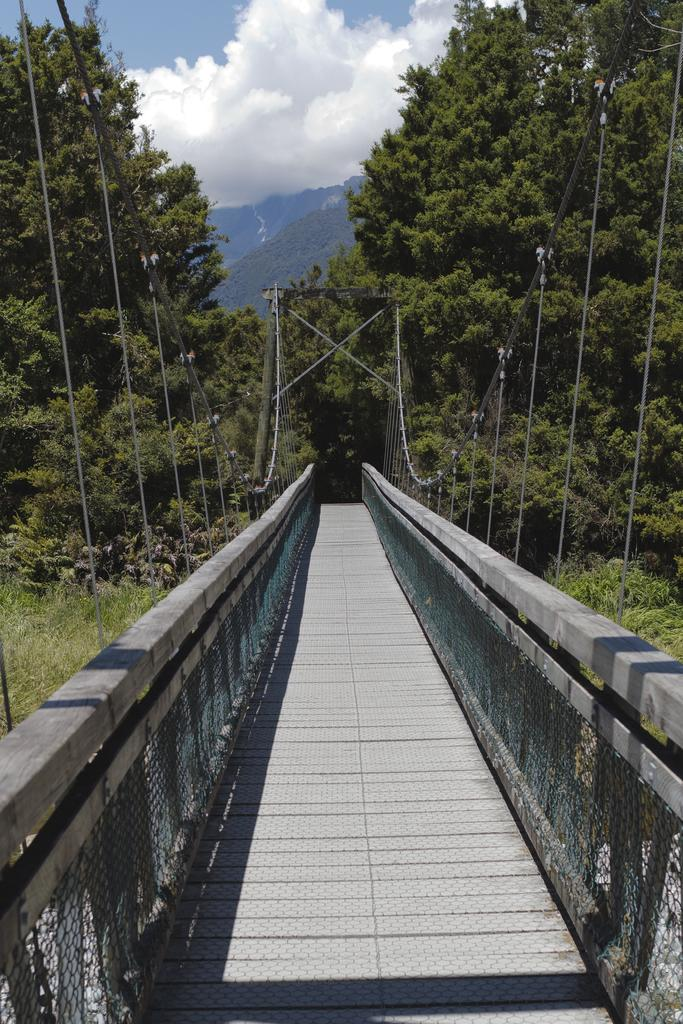What type of bridge is in the image? There is a rope bridge in the image. What can be seen on the other side of the bridge? Trees and mountains are visible on the other side of the bridge. What color is the ink used to write on the rope bridge? There is no ink or writing present on the rope bridge in the image. 